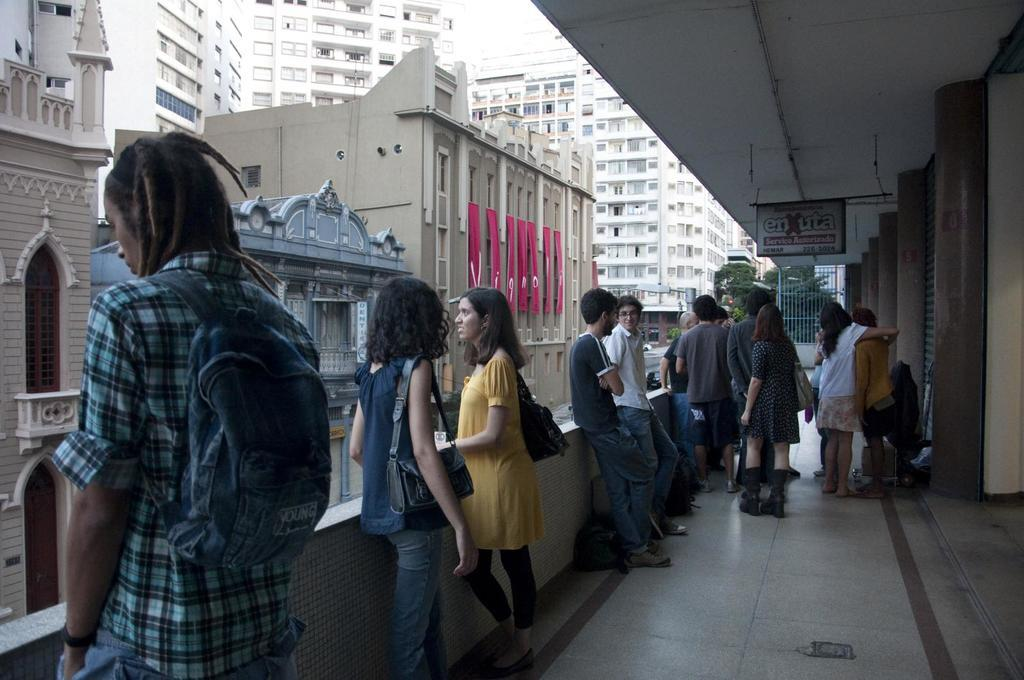What are the people in the image doing? The people in the image are standing in the corridors. What can be seen on the left side of the image? There are buildings on the left side of the image. What type of buildings are visible in the background of the image? There are tall buildings in the background of the image. What material is the floor made of in the image? The floor in the image is made of marble. What type of secretary can be seen working in the image? There is no secretary present in the image. What effect does the flight have on the people in the image? There is no flight present in the image, so no effect can be observed. 